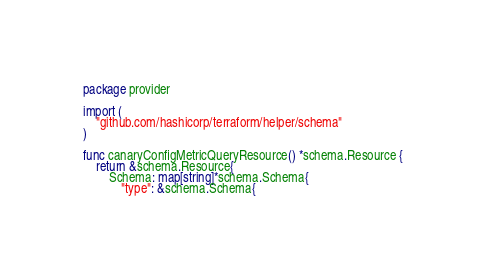Convert code to text. <code><loc_0><loc_0><loc_500><loc_500><_Go_>package provider

import (
	"github.com/hashicorp/terraform/helper/schema"
)

func canaryConfigMetricQueryResource() *schema.Resource {
	return &schema.Resource{
		Schema: map[string]*schema.Schema{
			"type": &schema.Schema{</code> 